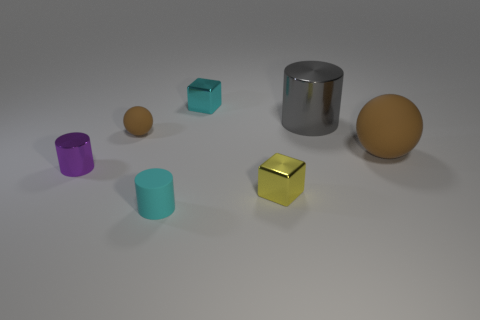What is the big brown ball made of?
Your answer should be very brief. Rubber. Do the purple metal thing and the gray cylinder have the same size?
Provide a short and direct response. No. What number of blocks are either brown things or tiny things?
Keep it short and to the point. 2. There is a cylinder right of the cyan object in front of the purple metal cylinder; what is its color?
Provide a succinct answer. Gray. Are there fewer small spheres that are to the right of the yellow metallic block than small yellow objects that are behind the small purple cylinder?
Your answer should be very brief. No. Does the yellow thing have the same size as the thing in front of the yellow shiny block?
Give a very brief answer. Yes. What shape is the object that is on the left side of the big matte object and on the right side of the tiny yellow shiny cube?
Offer a terse response. Cylinder. What is the size of the purple thing that is the same material as the small yellow block?
Your answer should be compact. Small. What number of purple metallic objects are behind the metallic block that is behind the tiny purple object?
Provide a short and direct response. 0. Is the material of the large cylinder that is behind the small matte ball the same as the tiny brown thing?
Provide a short and direct response. No. 